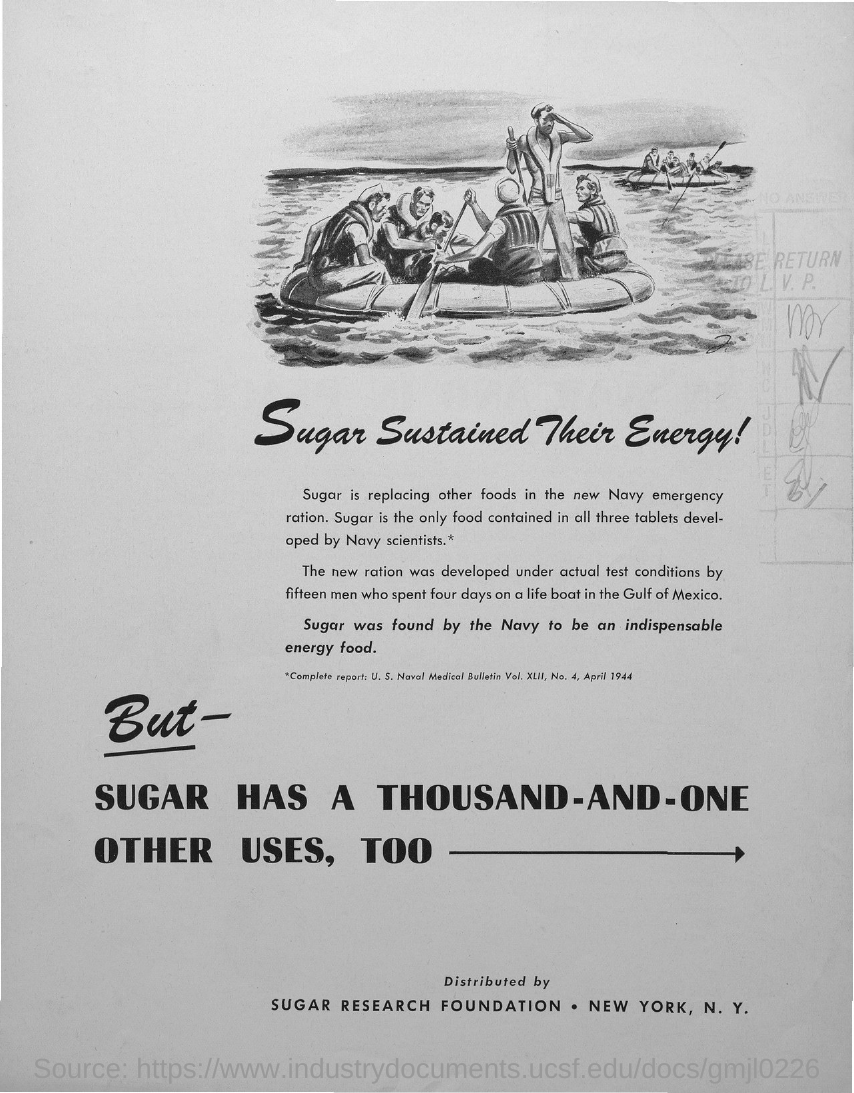Which is the only food contained in all three tablets developed by Navy scientists?
Provide a succinct answer. SUGAR. 